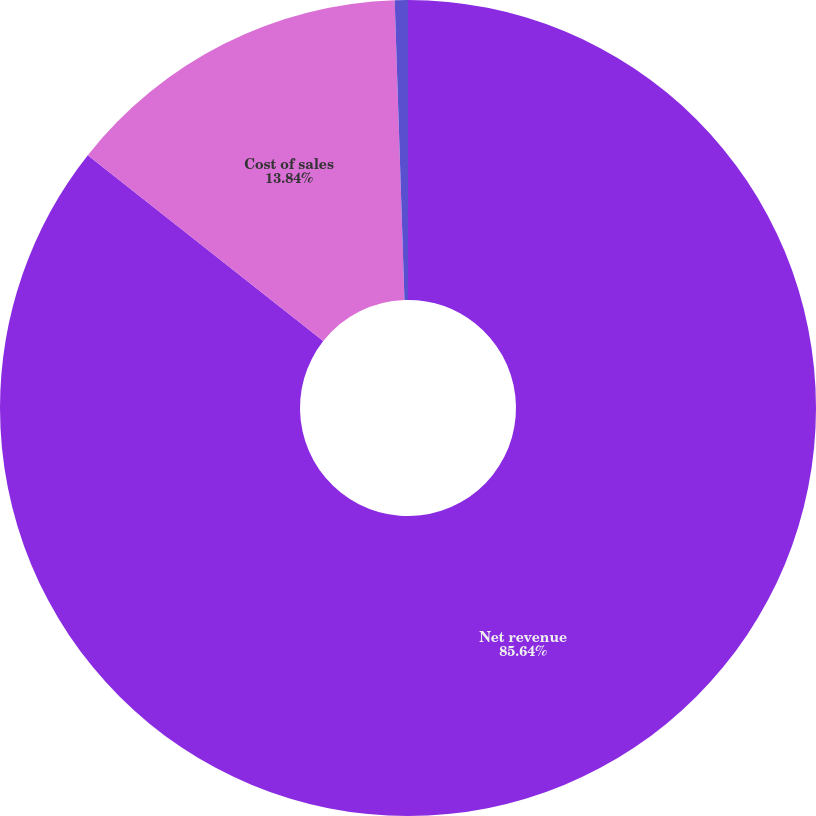Convert chart. <chart><loc_0><loc_0><loc_500><loc_500><pie_chart><fcel>Net revenue<fcel>Cost of sales<fcel>Selling general and<nl><fcel>85.63%<fcel>13.84%<fcel>0.52%<nl></chart> 